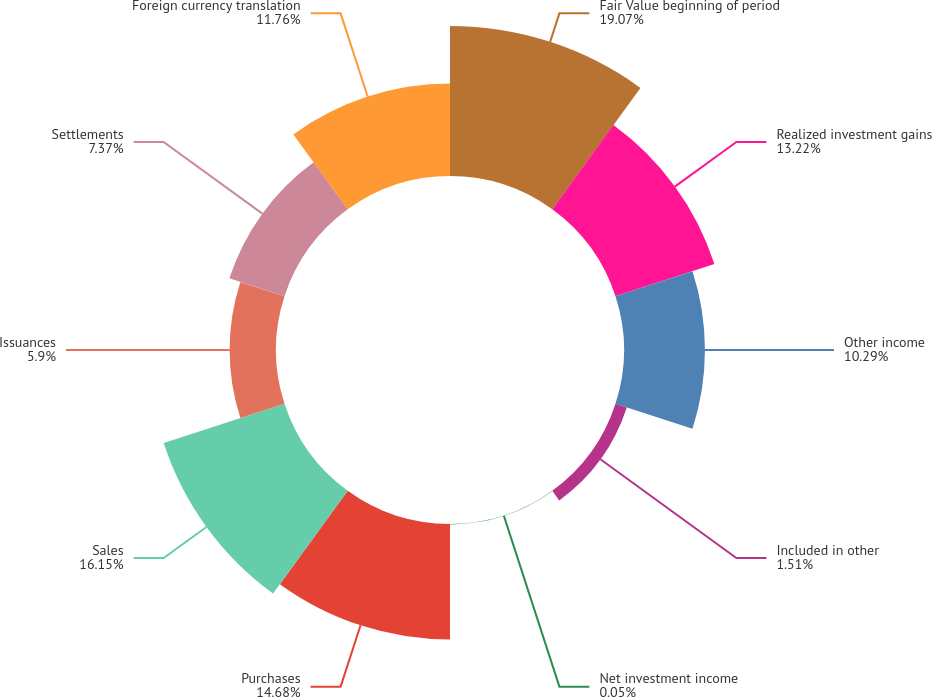Convert chart to OTSL. <chart><loc_0><loc_0><loc_500><loc_500><pie_chart><fcel>Fair Value beginning of period<fcel>Realized investment gains<fcel>Other income<fcel>Included in other<fcel>Net investment income<fcel>Purchases<fcel>Sales<fcel>Issuances<fcel>Settlements<fcel>Foreign currency translation<nl><fcel>19.07%<fcel>13.22%<fcel>10.29%<fcel>1.51%<fcel>0.05%<fcel>14.68%<fcel>16.15%<fcel>5.9%<fcel>7.37%<fcel>11.76%<nl></chart> 